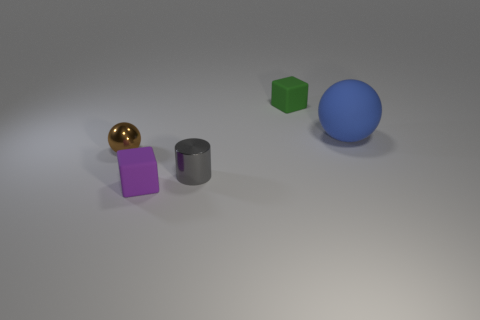Is there anything else that is the same size as the blue sphere?
Provide a succinct answer. No. How many objects are either small rubber things to the left of the tiny metal cylinder or blocks that are in front of the large blue matte ball?
Your response must be concise. 1. Is there any other thing that has the same color as the large thing?
Your answer should be compact. No. There is a small rubber thing that is on the right side of the matte cube in front of the tiny cube that is right of the tiny purple object; what is its color?
Provide a succinct answer. Green. What is the size of the metallic thing that is in front of the sphere that is in front of the large sphere?
Offer a very short reply. Small. What is the material of the thing that is left of the metal cylinder and behind the purple block?
Your answer should be compact. Metal. There is a green cube; is its size the same as the rubber block in front of the small cylinder?
Offer a terse response. Yes. Is there a green matte sphere?
Give a very brief answer. No. There is a tiny green object that is the same shape as the purple rubber object; what is it made of?
Your response must be concise. Rubber. How big is the cube on the left side of the rubber block that is behind the sphere on the right side of the green rubber thing?
Make the answer very short. Small. 